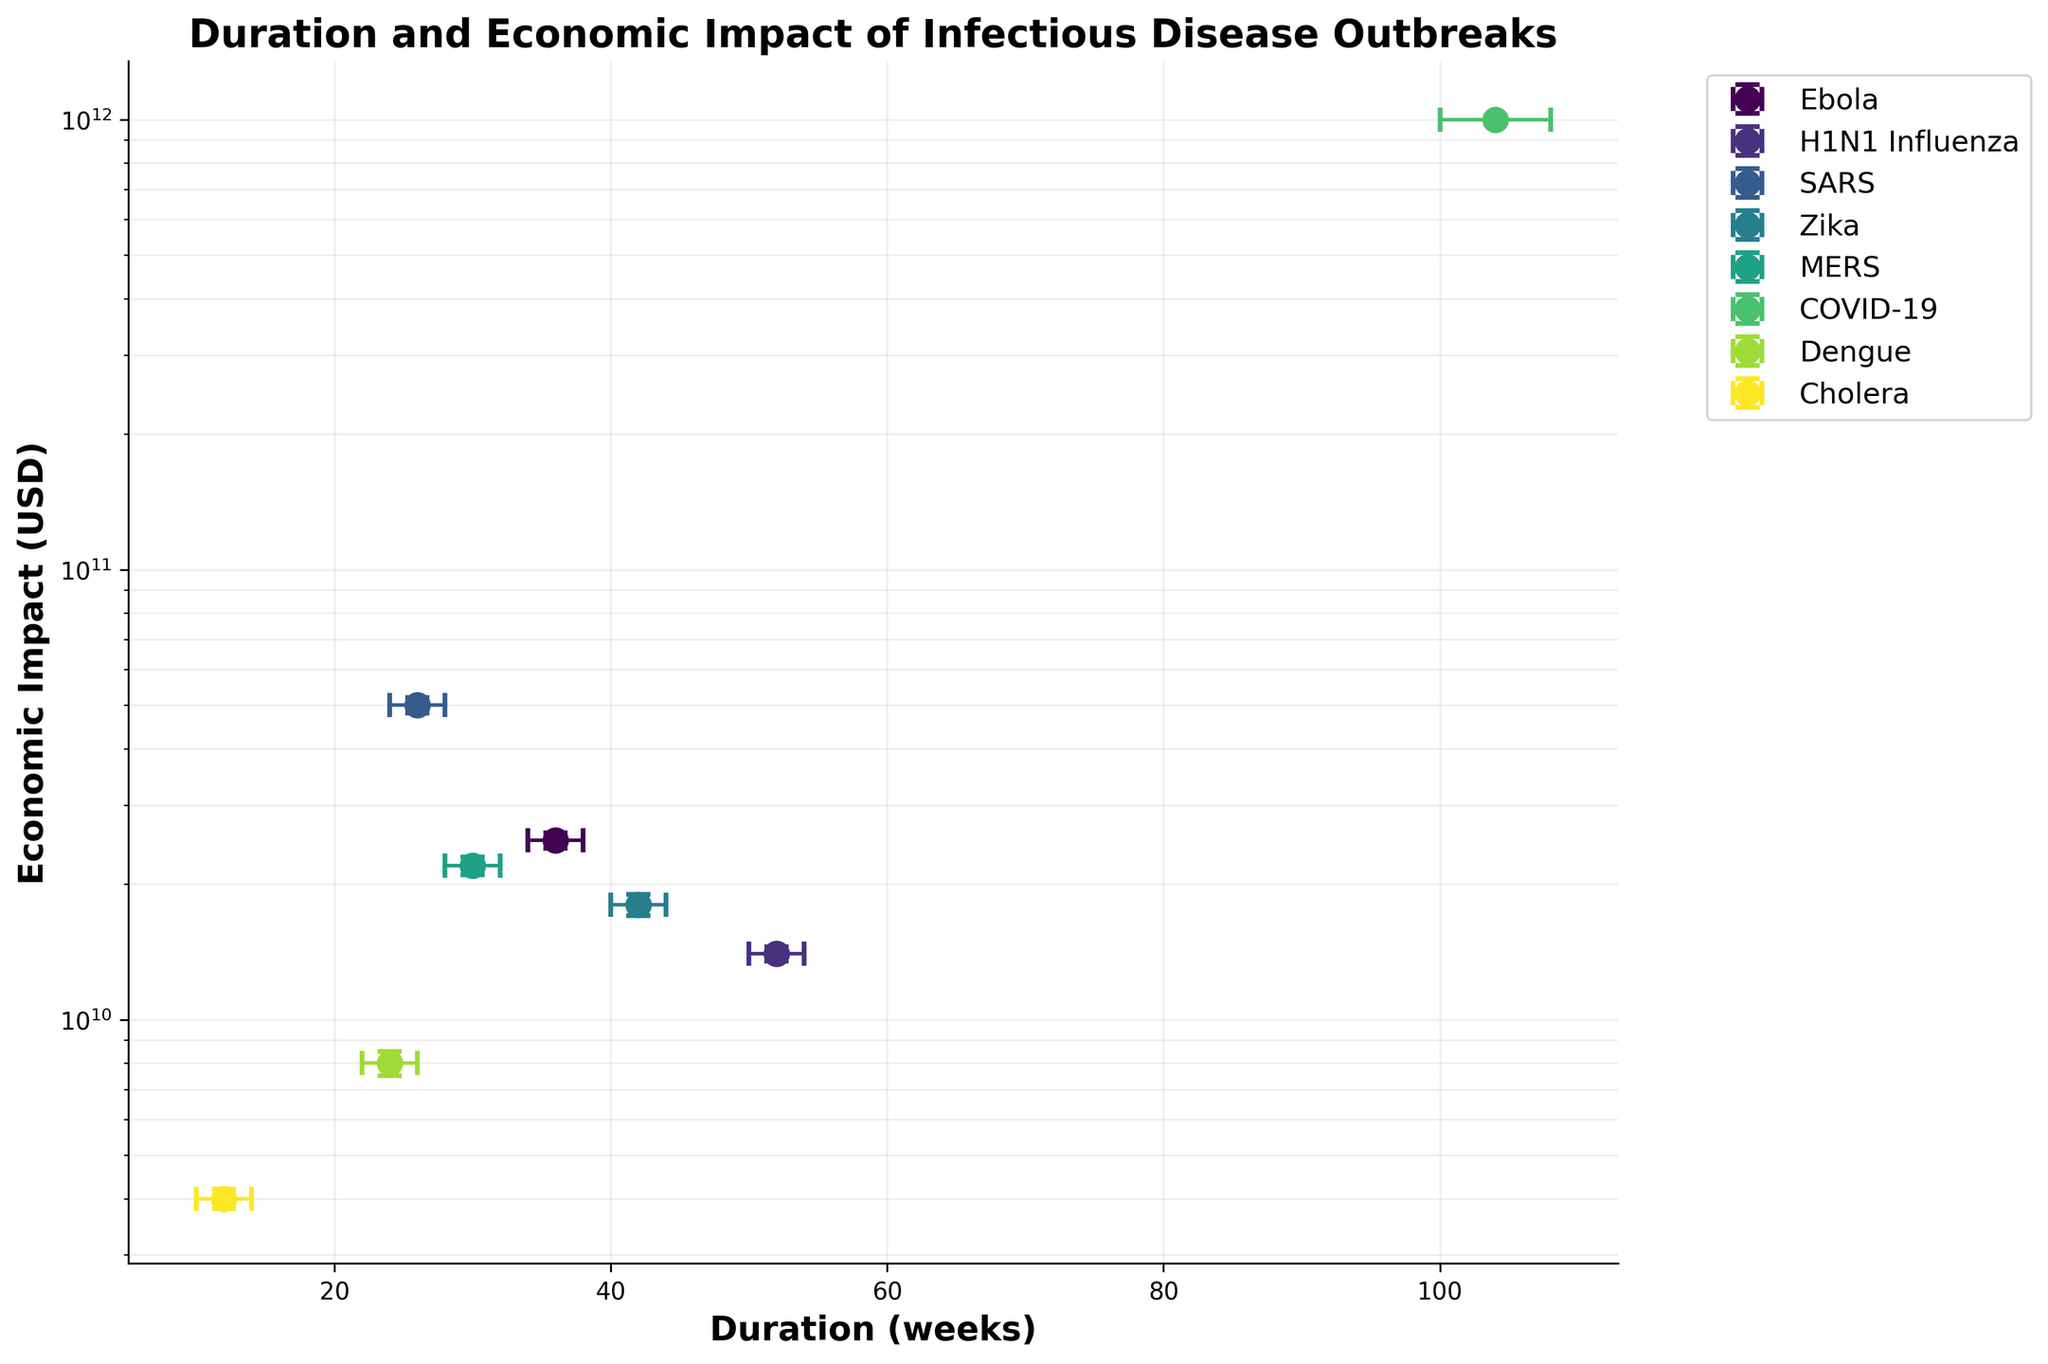What is the title of the plot? The title of the plot appears at the top center and reads "Duration and Economic Impact of Infectious Disease Outbreaks".
Answer: Duration and Economic Impact of Infectious Disease Outbreaks Which disease has the longest outbreak duration? Looking along the x-axis for the highest value, the disease that appears furthest to the right is COVID-19 at 104 weeks.
Answer: COVID-19 Which disease has the highest economic impact? By checking the highest point on the y-axis, the disease with the greatest economic impact is COVID-19, located at the top of the plot with an impact of $1,000,000,000,000.
Answer: COVID-19 What is the economic impact range for Ebola, as represented by the error bars? The error bars for Ebola on the y-axis extend from $24,000,000,000 to $26,000,000,000.
Answer: $24,000,000,000 to $26,000,000,000 How does the duration of Zika compare to Cholera? Zika's duration is located at 42 weeks, and Cholera’s duration is at 12 weeks. This shows that the Zika outbreak lasted 30 weeks longer than Cholera.
Answer: Zika lasted 30 weeks longer What is the average economic impact of SARS and H1N1 Influenza? Add the economic impacts of SARS ($50,000,000,000) and H1N1 Influenza ($14,000,000,000) and divide by 2: (50,000,000,000 + 14,000,000,000) / 2 = $32,000,000,000.
Answer: $32,000,000,000 Which disease has the smallest duration with the confidence intervals considered? Considering the error bars on the x-axis, Cholera has the smallest duration range, spanning from 10 to 14 weeks.
Answer: Cholera What is the duration range of COVID-19? COVID-19 has error bars on the x-axis stretching from 100 to 108 weeks, creating a duration range of 8 weeks.
Answer: 100 to 108 weeks Compare the economic impact of MERS and Dengue. Which one is higher, and by how much? MERS has an economic impact located at $22,000,000,000, and Dengue at $8,000,000,000. The difference is $22,000,000,000 - $8,000,000,000 = $14,000,000,000, meaning MERS’s impact is higher by $14,000,000,000.
Answer: MERS by $14,000,000,000 Does the duration of Dengue fall within the confidence interval range of SARS's duration? SARS's duration has a range from 24 to 28 weeks. Dengue has a recorded duration of 24 weeks which falls within this range.
Answer: Yes 